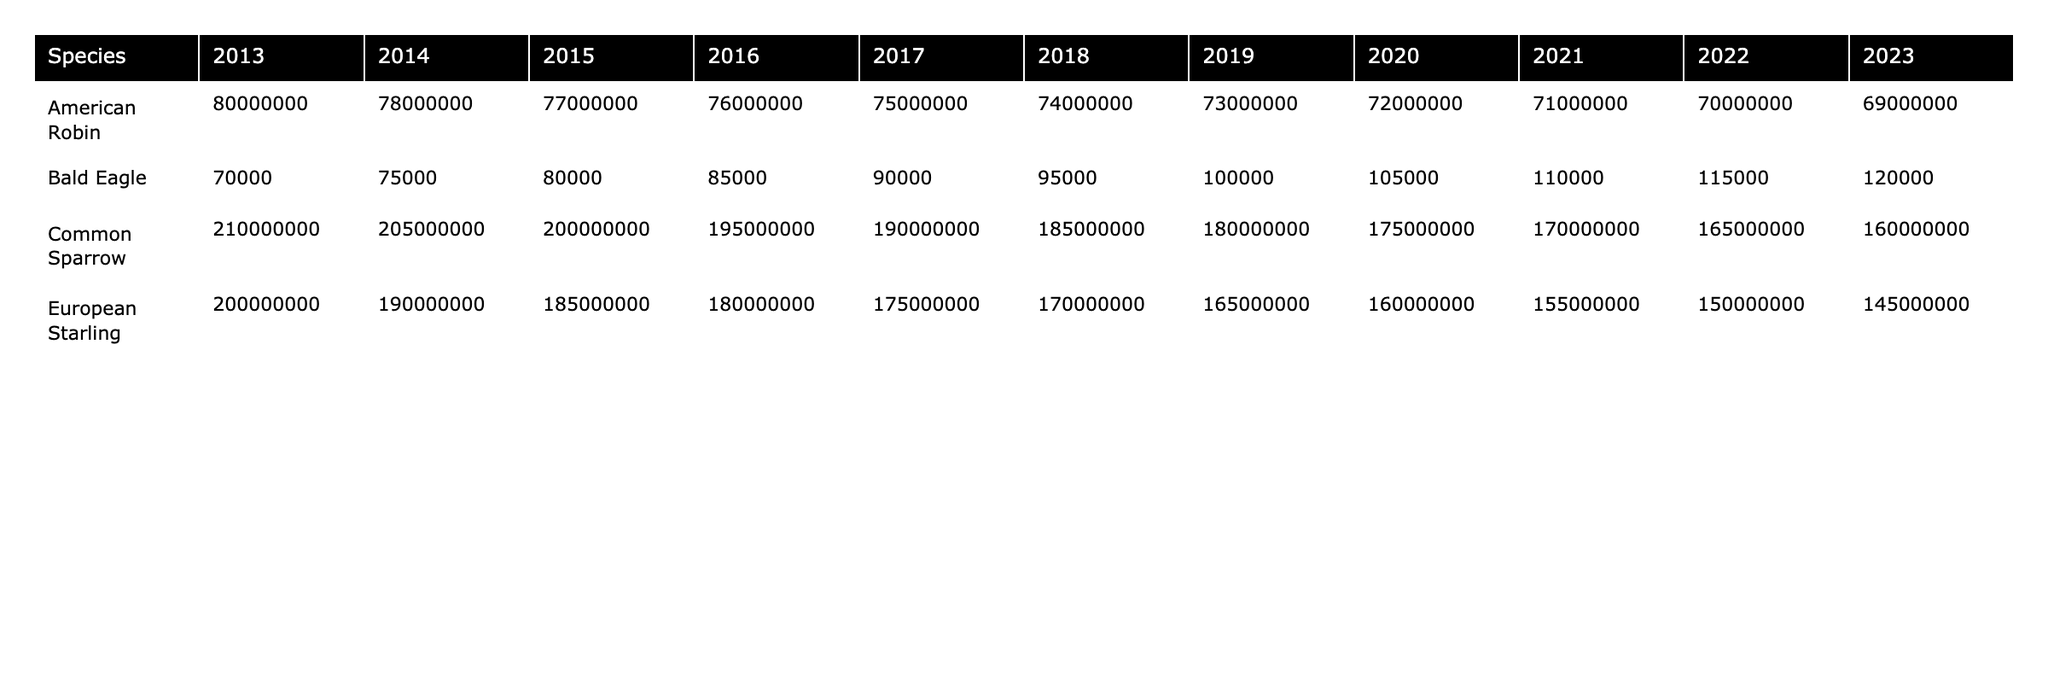What was the population estimate of the American Robin in 2018? The table shows the population estimate for each species by year, and for the American Robin in 2018, the population estimate is directly listed as 74,000,000.
Answer: 74,000,000 What was the trend in the Bald Eagle population from 2013 to 2023? The Bald Eagle's population trend shows consistent increases from 70,000 in 2013 to 120,000 in 2023, with only one year (2017) marked as stable.
Answer: Increase What was the population estimate of the European Starling in 2021? Referring to the table, the population estimate for the European Starling in 2021 is listed as 155,000,000.
Answer: 155,000,000 Which species had the highest population estimate in 2013? By looking at the 2013 row in the table, the Common Sparrow has the highest population estimate of 210,000,000 compared to the other species listed.
Answer: Common Sparrow Did the American Robin's population increase at any point in the last decade? By reviewing the population estimates from 2013 to 2023 for the American Robin, all observed years indicate either a decrease or stability, signifying no increase occurred during this period.
Answer: No What is the total population estimate of the Common Sparrow from 2013 to 2023? To find the total, we sum the population estimates from 2013 (210,000,000) to 2023 (160,000,000): 210,000,000 + 205,000,000 + 200,000,000 + 195,000,000 + 190,000,000 + 185,000,000 + 180,000,000 + 175,000,000 + 170,000,000 + 165,000,000 + 160,000,000 = 2,085,000,000.
Answer: 2,085,000,000 What is the average population estimate of the European Starling over the last decade? Adding the population estimates from 2013 to 2023 gives us 200,000,000 + 190,000,000 + 185,000,000 + 180,000,000 + 175,000,000 + 170,000,000 + 165,000,000 + 160,000,000 + 155,000,000 + 150,000,000 + 145,000,000 = 1,955,000,000. Dividing by the number of years (11) gives us an average of 177,727,273.
Answer: 177,727,273 Which species had a stable population in 2022? The table shows that both the Bald Eagle and the European Starling were marked as stable in 2022.
Answer: Bald Eagle and European Starling What was the decrease in population of the American Robin from 2013 to 2023? The population decreased from 80,000,000 in 2013 to 69,000,000 in 2023. The difference is 80,000,000 - 69,000,000 = 11,000,000.
Answer: 11,000,000 Was there ever a year in the last decade when the Bald Eagle population decreased? Checking the yearly estimates, all years show either stable or increasing trends, confirming that there was no decline for the Bald Eagle.
Answer: No What is the overall trend of the Common Sparrow's population over the last decade? Evaluating the estimates from 2013 to 2023, the population shows a declining trend, starting at 210,000,000 and ending at 160,000,000, with only a few years marked as stable.
Answer: Decreasing 